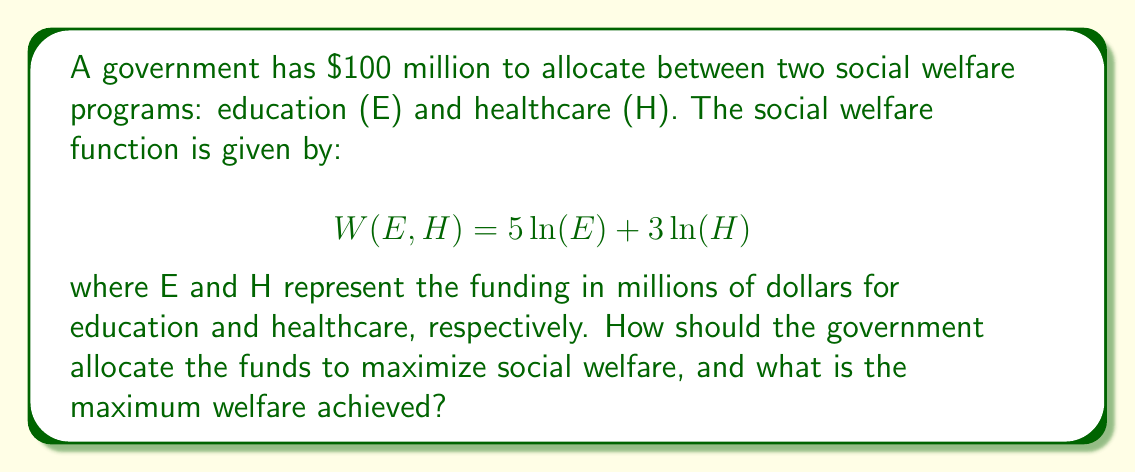Provide a solution to this math problem. To solve this optimization problem, we can use the method of Lagrange multipliers:

1. Set up the Lagrangian function:
   $$L(E,H,\lambda) = 5\ln(E) + 3\ln(H) + \lambda(100 - E - H)$$

2. Take partial derivatives and set them equal to zero:
   $$\frac{\partial L}{\partial E} = \frac{5}{E} - \lambda = 0$$
   $$\frac{\partial L}{\partial H} = \frac{3}{H} - \lambda = 0$$
   $$\frac{\partial L}{\partial \lambda} = 100 - E - H = 0$$

3. From the first two equations:
   $$\frac{5}{E} = \frac{3}{H}$$
   $$5H = 3E$$

4. Substitute this into the budget constraint:
   $$100 - E - \frac{3E}{5} = 0$$
   $$100 = E + \frac{3E}{5} = \frac{8E}{5}$$
   $$E = 62.5$$

5. Calculate H:
   $$H = 100 - 62.5 = 37.5$$

6. Calculate the maximum welfare:
   $$W(62.5, 37.5) = 5\ln(62.5) + 3\ln(37.5) = 20.97$$

This allocation satisfies the optimality conditions and the budget constraint, maximizing social welfare.
Answer: The optimal allocation is $62.5 million for education and $37.5 million for healthcare. The maximum social welfare achieved is 20.97 units. 